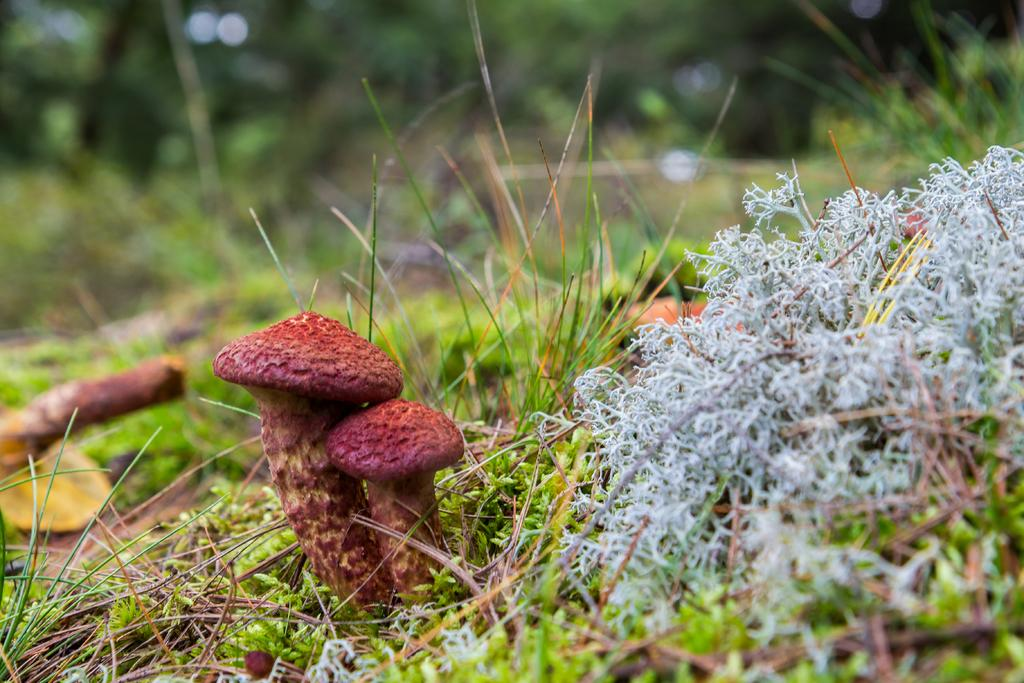What type of surface can be seen in the image? There is a path with grass in the image. What decorates the path? The path has flowers. What additional feature can be found on the path? There are mushrooms on the path, which are dark pink in color. What can be seen in the distance in the image? There are trees in the background of the image. What type of cord is used to hang the land in the image? There is no mention of a cord or land in the image. The image describes a path with grass, flowers, and mushrooms, along with trees in the background. 